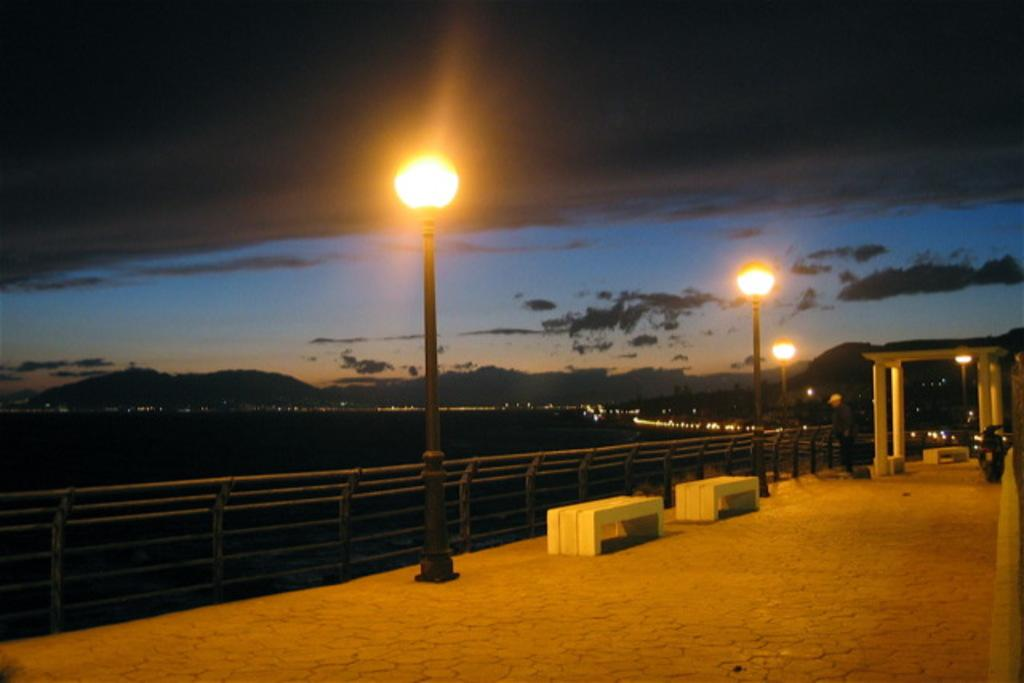How many benches are in the image? There are two benches in the image. Where are the benches located? The benches are on the land. What can be seen on the poles in the image? There are yellow lights on the poles in the image. What is visible in the sky in the background of the image? There are clouds visible in the sky in the background of the image. What type of music can be heard playing from the benches in the image? There is no music present in the image; it only features benches, poles with yellow lights, and clouds in the sky. 